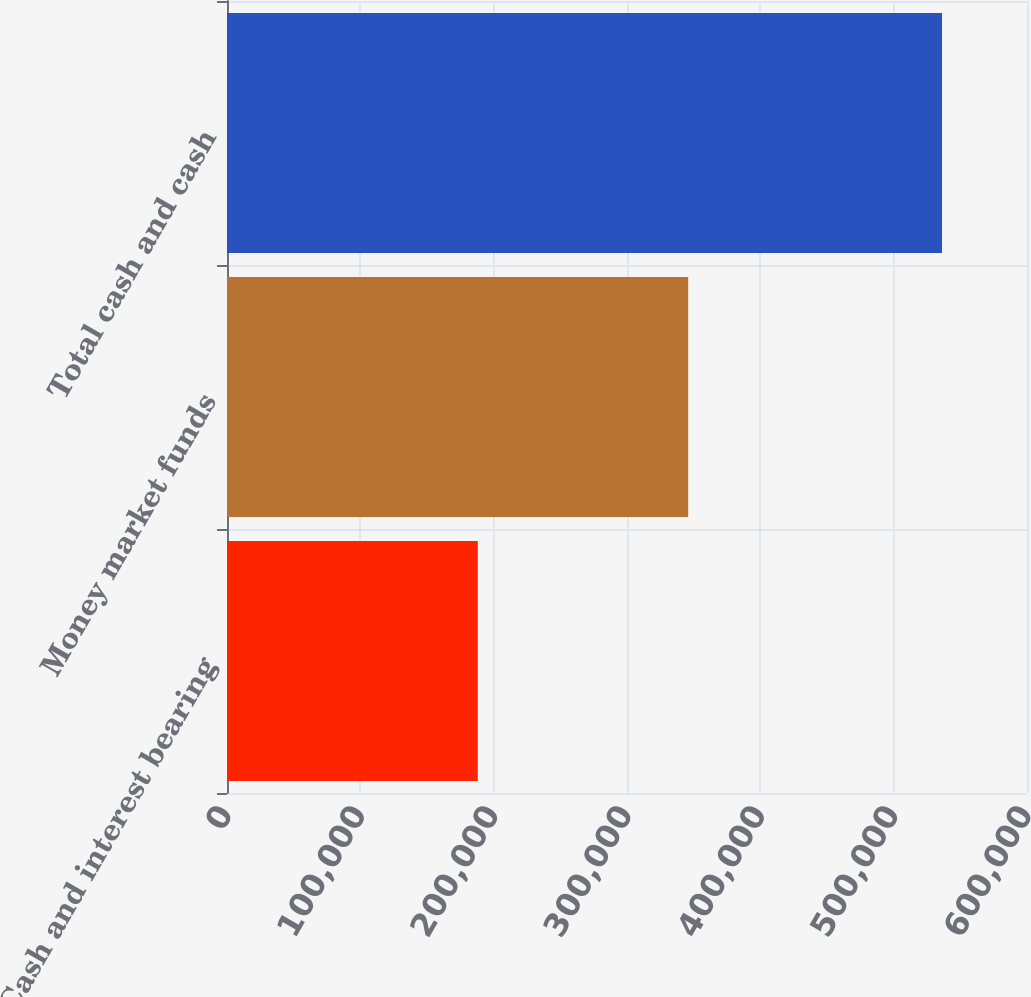<chart> <loc_0><loc_0><loc_500><loc_500><bar_chart><fcel>Cash and interest bearing<fcel>Money market funds<fcel>Total cash and cash<nl><fcel>188088<fcel>345872<fcel>536260<nl></chart> 